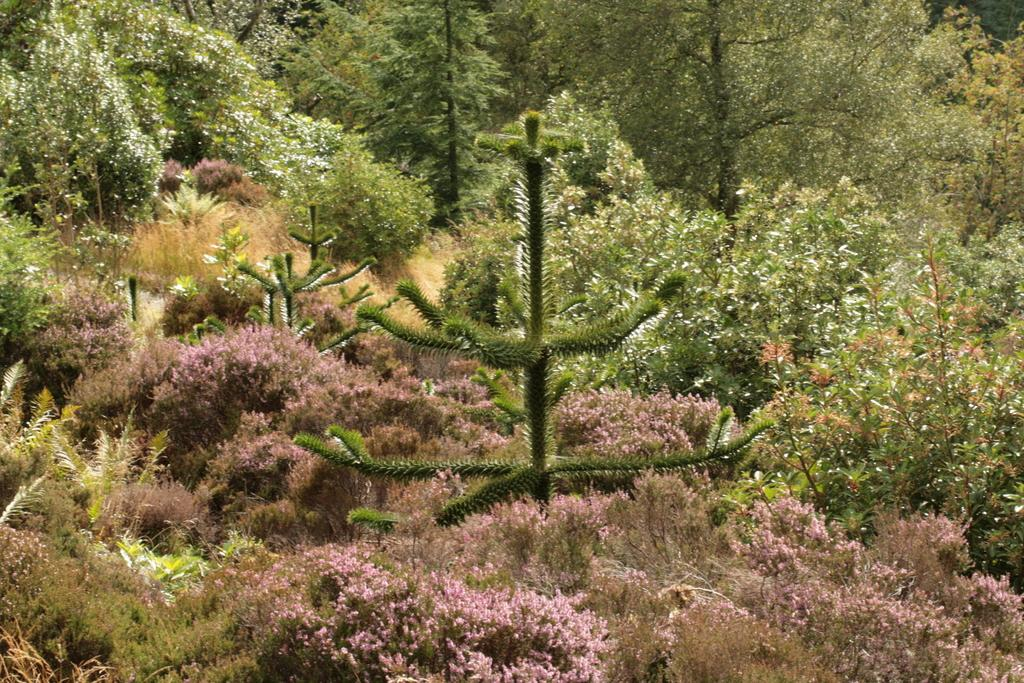Where was the image taken? The image was taken outdoors. What can be seen in the image besides the outdoor setting? There are many trees and plants with stems, branches, and green leaves in the image. How are the trees and plants positioned in the image? The trees and plants are on the ground. What is the distribution of the plants in the image? The question about the distribution of the plants is not relevant to the image, as it does not contain any information about the arrangement or layout of the plants. 